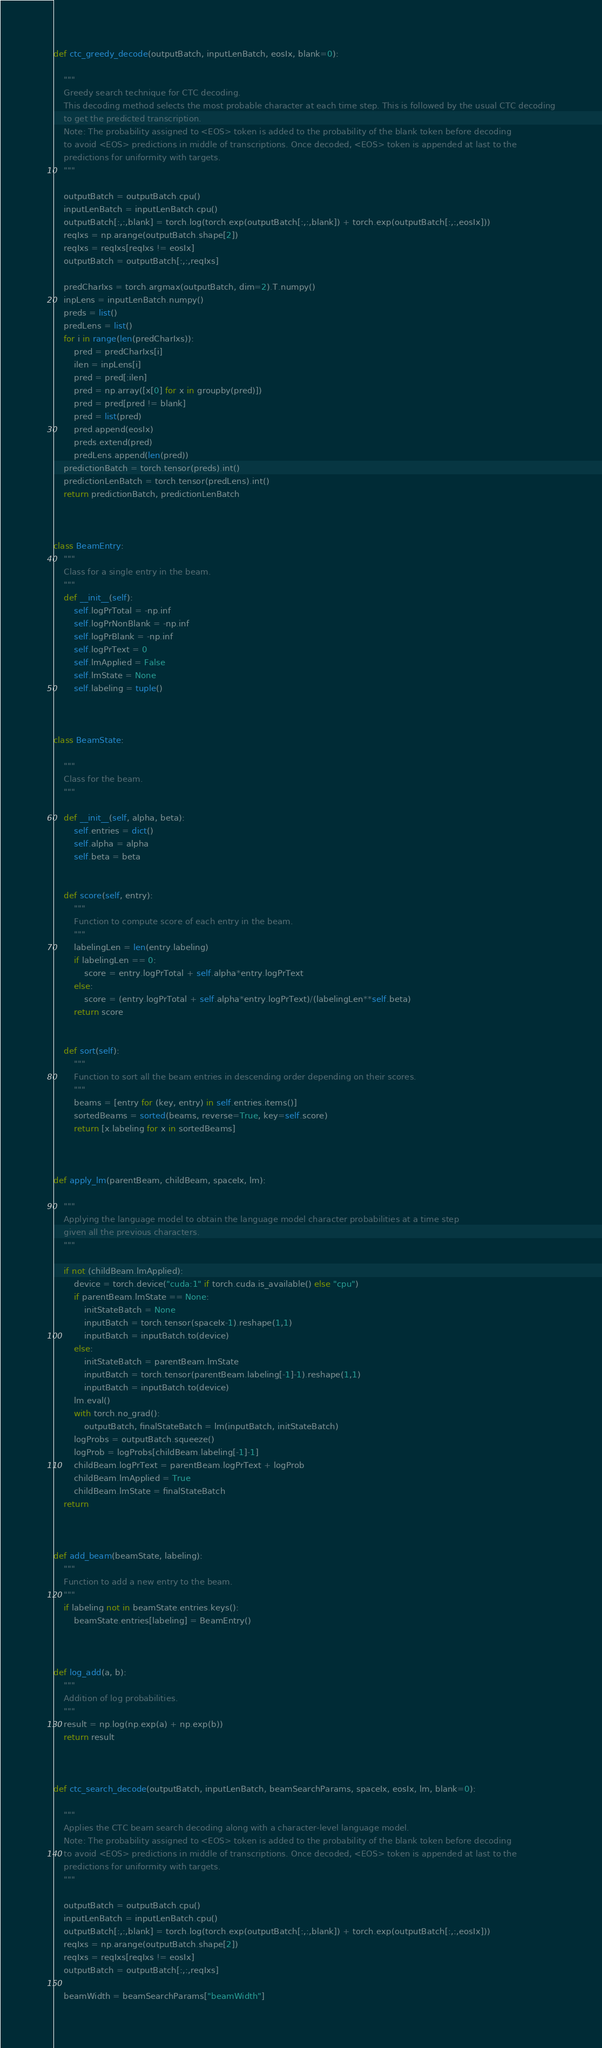<code> <loc_0><loc_0><loc_500><loc_500><_Python_>

def ctc_greedy_decode(outputBatch, inputLenBatch, eosIx, blank=0):

    """
    Greedy search technique for CTC decoding.
    This decoding method selects the most probable character at each time step. This is followed by the usual CTC decoding
    to get the predicted transcription.
    Note: The probability assigned to <EOS> token is added to the probability of the blank token before decoding
    to avoid <EOS> predictions in middle of transcriptions. Once decoded, <EOS> token is appended at last to the
    predictions for uniformity with targets.
    """

    outputBatch = outputBatch.cpu()
    inputLenBatch = inputLenBatch.cpu()
    outputBatch[:,:,blank] = torch.log(torch.exp(outputBatch[:,:,blank]) + torch.exp(outputBatch[:,:,eosIx]))
    reqIxs = np.arange(outputBatch.shape[2])
    reqIxs = reqIxs[reqIxs != eosIx]
    outputBatch = outputBatch[:,:,reqIxs]

    predCharIxs = torch.argmax(outputBatch, dim=2).T.numpy()
    inpLens = inputLenBatch.numpy()
    preds = list()
    predLens = list()
    for i in range(len(predCharIxs)):
        pred = predCharIxs[i]
        ilen = inpLens[i]
        pred = pred[:ilen]
        pred = np.array([x[0] for x in groupby(pred)])
        pred = pred[pred != blank]
        pred = list(pred)
        pred.append(eosIx)
        preds.extend(pred)
        predLens.append(len(pred))
    predictionBatch = torch.tensor(preds).int()
    predictionLenBatch = torch.tensor(predLens).int()
    return predictionBatch, predictionLenBatch



class BeamEntry:
    """
    Class for a single entry in the beam.
    """
    def __init__(self):
        self.logPrTotal = -np.inf
        self.logPrNonBlank = -np.inf
        self.logPrBlank = -np.inf
        self.logPrText = 0
        self.lmApplied = False
        self.lmState = None
        self.labeling = tuple()



class BeamState:

    """
    Class for the beam.
    """

    def __init__(self, alpha, beta):
        self.entries = dict()
        self.alpha = alpha
        self.beta = beta


    def score(self, entry):
        """
        Function to compute score of each entry in the beam.
        """
        labelingLen = len(entry.labeling)
        if labelingLen == 0:
            score = entry.logPrTotal + self.alpha*entry.logPrText
        else:
            score = (entry.logPrTotal + self.alpha*entry.logPrText)/(labelingLen**self.beta)
        return score


    def sort(self):
        """
        Function to sort all the beam entries in descending order depending on their scores.
        """
        beams = [entry for (key, entry) in self.entries.items()]
        sortedBeams = sorted(beams, reverse=True, key=self.score)
        return [x.labeling for x in sortedBeams]



def apply_lm(parentBeam, childBeam, spaceIx, lm):

    """
    Applying the language model to obtain the language model character probabilities at a time step
    given all the previous characters.
    """

    if not (childBeam.lmApplied):
        device = torch.device("cuda:1" if torch.cuda.is_available() else "cpu")
        if parentBeam.lmState == None:
            initStateBatch = None
            inputBatch = torch.tensor(spaceIx-1).reshape(1,1)
            inputBatch = inputBatch.to(device)
        else:
            initStateBatch = parentBeam.lmState
            inputBatch = torch.tensor(parentBeam.labeling[-1]-1).reshape(1,1)
            inputBatch = inputBatch.to(device)
        lm.eval()
        with torch.no_grad():
            outputBatch, finalStateBatch = lm(inputBatch, initStateBatch)
        logProbs = outputBatch.squeeze()
        logProb = logProbs[childBeam.labeling[-1]-1]
        childBeam.logPrText = parentBeam.logPrText + logProb
        childBeam.lmApplied = True
        childBeam.lmState = finalStateBatch
    return



def add_beam(beamState, labeling):
    """
    Function to add a new entry to the beam.
    """
    if labeling not in beamState.entries.keys():
        beamState.entries[labeling] = BeamEntry()



def log_add(a, b):
    """
    Addition of log probabilities.
    """
    result = np.log(np.exp(a) + np.exp(b))
    return result



def ctc_search_decode(outputBatch, inputLenBatch, beamSearchParams, spaceIx, eosIx, lm, blank=0):

    """
    Applies the CTC beam search decoding along with a character-level language model.
    Note: The probability assigned to <EOS> token is added to the probability of the blank token before decoding
    to avoid <EOS> predictions in middle of transcriptions. Once decoded, <EOS> token is appended at last to the
    predictions for uniformity with targets.
    """

    outputBatch = outputBatch.cpu()
    inputLenBatch = inputLenBatch.cpu()
    outputBatch[:,:,blank] = torch.log(torch.exp(outputBatch[:,:,blank]) + torch.exp(outputBatch[:,:,eosIx]))
    reqIxs = np.arange(outputBatch.shape[2])
    reqIxs = reqIxs[reqIxs != eosIx]
    outputBatch = outputBatch[:,:,reqIxs]

    beamWidth = beamSearchParams["beamWidth"]</code> 